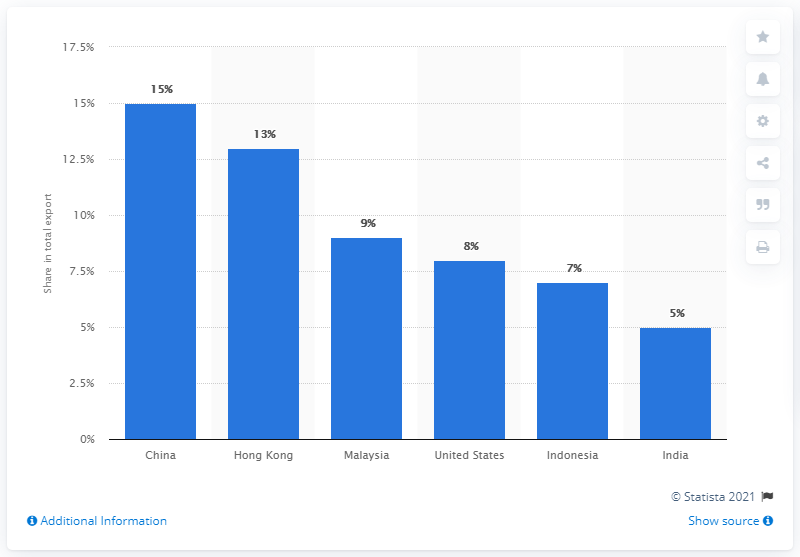Point out several critical features in this image. In 2019, China was the most significant export partner of Singapore. 